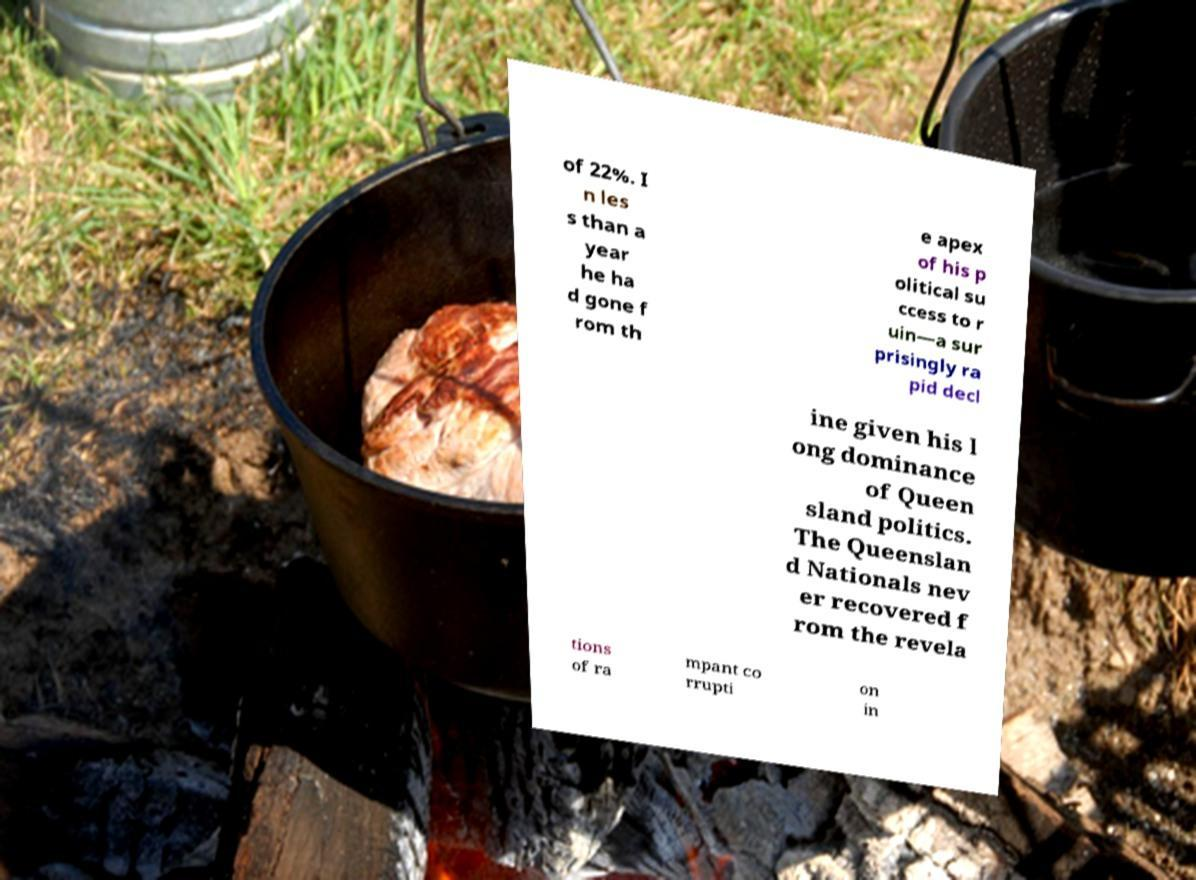I need the written content from this picture converted into text. Can you do that? of 22%. I n les s than a year he ha d gone f rom th e apex of his p olitical su ccess to r uin—a sur prisingly ra pid decl ine given his l ong dominance of Queen sland politics. The Queenslan d Nationals nev er recovered f rom the revela tions of ra mpant co rrupti on in 